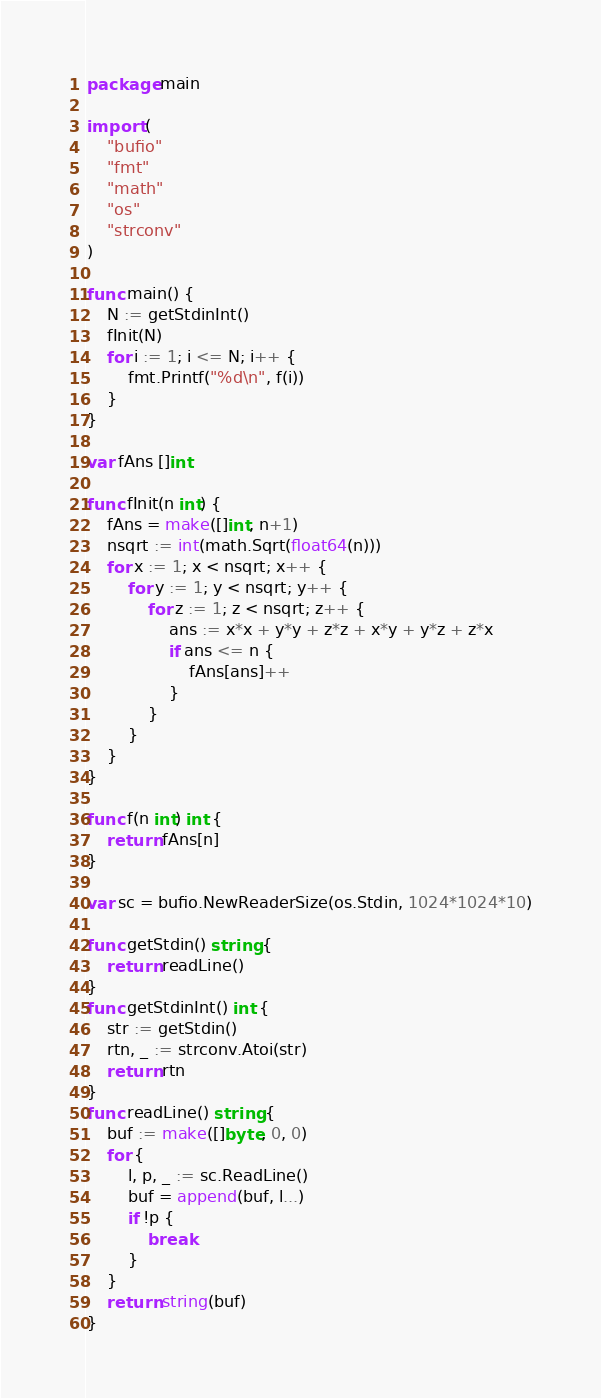<code> <loc_0><loc_0><loc_500><loc_500><_Go_>package main

import (
	"bufio"
	"fmt"
	"math"
	"os"
	"strconv"
)

func main() {
	N := getStdinInt()
	fInit(N)
	for i := 1; i <= N; i++ {
		fmt.Printf("%d\n", f(i))
	}
}

var fAns []int

func fInit(n int) {
	fAns = make([]int, n+1)
	nsqrt := int(math.Sqrt(float64(n)))
	for x := 1; x < nsqrt; x++ {
		for y := 1; y < nsqrt; y++ {
			for z := 1; z < nsqrt; z++ {
				ans := x*x + y*y + z*z + x*y + y*z + z*x
				if ans <= n {
					fAns[ans]++
				}
			}
		}
	}
}

func f(n int) int {
	return fAns[n]
}

var sc = bufio.NewReaderSize(os.Stdin, 1024*1024*10)

func getStdin() string {
	return readLine()
}
func getStdinInt() int {
	str := getStdin()
	rtn, _ := strconv.Atoi(str)
	return rtn
}
func readLine() string {
	buf := make([]byte, 0, 0)
	for {
		l, p, _ := sc.ReadLine()
		buf = append(buf, l...)
		if !p {
			break
		}
	}
	return string(buf)
}
</code> 